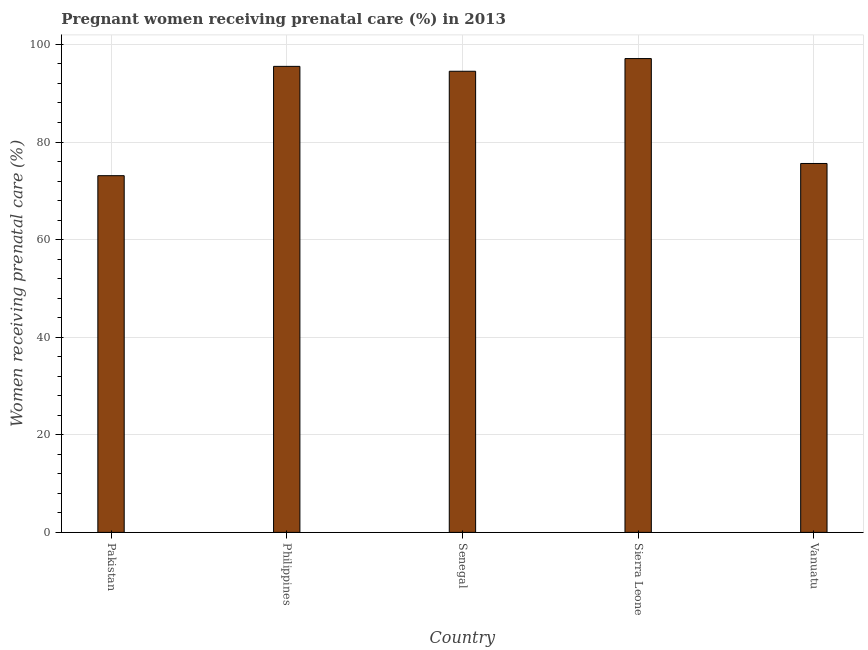Does the graph contain grids?
Your answer should be compact. Yes. What is the title of the graph?
Provide a short and direct response. Pregnant women receiving prenatal care (%) in 2013. What is the label or title of the Y-axis?
Ensure brevity in your answer.  Women receiving prenatal care (%). What is the percentage of pregnant women receiving prenatal care in Pakistan?
Ensure brevity in your answer.  73.1. Across all countries, what is the maximum percentage of pregnant women receiving prenatal care?
Provide a succinct answer. 97.1. Across all countries, what is the minimum percentage of pregnant women receiving prenatal care?
Your answer should be very brief. 73.1. In which country was the percentage of pregnant women receiving prenatal care maximum?
Ensure brevity in your answer.  Sierra Leone. What is the sum of the percentage of pregnant women receiving prenatal care?
Provide a short and direct response. 435.8. What is the average percentage of pregnant women receiving prenatal care per country?
Provide a short and direct response. 87.16. What is the median percentage of pregnant women receiving prenatal care?
Provide a short and direct response. 94.5. In how many countries, is the percentage of pregnant women receiving prenatal care greater than 4 %?
Your answer should be very brief. 5. What is the ratio of the percentage of pregnant women receiving prenatal care in Sierra Leone to that in Vanuatu?
Offer a very short reply. 1.28. Is the percentage of pregnant women receiving prenatal care in Philippines less than that in Senegal?
Ensure brevity in your answer.  No. Is the difference between the percentage of pregnant women receiving prenatal care in Philippines and Senegal greater than the difference between any two countries?
Provide a succinct answer. No. What is the difference between the highest and the second highest percentage of pregnant women receiving prenatal care?
Your answer should be compact. 1.6. What is the difference between the highest and the lowest percentage of pregnant women receiving prenatal care?
Your response must be concise. 24. How many countries are there in the graph?
Your answer should be very brief. 5. Are the values on the major ticks of Y-axis written in scientific E-notation?
Offer a terse response. No. What is the Women receiving prenatal care (%) of Pakistan?
Keep it short and to the point. 73.1. What is the Women receiving prenatal care (%) in Philippines?
Keep it short and to the point. 95.5. What is the Women receiving prenatal care (%) in Senegal?
Offer a terse response. 94.5. What is the Women receiving prenatal care (%) of Sierra Leone?
Offer a terse response. 97.1. What is the Women receiving prenatal care (%) in Vanuatu?
Provide a succinct answer. 75.6. What is the difference between the Women receiving prenatal care (%) in Pakistan and Philippines?
Ensure brevity in your answer.  -22.4. What is the difference between the Women receiving prenatal care (%) in Pakistan and Senegal?
Give a very brief answer. -21.4. What is the difference between the Women receiving prenatal care (%) in Pakistan and Vanuatu?
Offer a very short reply. -2.5. What is the difference between the Women receiving prenatal care (%) in Philippines and Sierra Leone?
Make the answer very short. -1.6. What is the difference between the Women receiving prenatal care (%) in Philippines and Vanuatu?
Your response must be concise. 19.9. What is the ratio of the Women receiving prenatal care (%) in Pakistan to that in Philippines?
Provide a succinct answer. 0.77. What is the ratio of the Women receiving prenatal care (%) in Pakistan to that in Senegal?
Offer a terse response. 0.77. What is the ratio of the Women receiving prenatal care (%) in Pakistan to that in Sierra Leone?
Keep it short and to the point. 0.75. What is the ratio of the Women receiving prenatal care (%) in Pakistan to that in Vanuatu?
Provide a succinct answer. 0.97. What is the ratio of the Women receiving prenatal care (%) in Philippines to that in Senegal?
Provide a short and direct response. 1.01. What is the ratio of the Women receiving prenatal care (%) in Philippines to that in Sierra Leone?
Provide a short and direct response. 0.98. What is the ratio of the Women receiving prenatal care (%) in Philippines to that in Vanuatu?
Your response must be concise. 1.26. What is the ratio of the Women receiving prenatal care (%) in Sierra Leone to that in Vanuatu?
Offer a terse response. 1.28. 